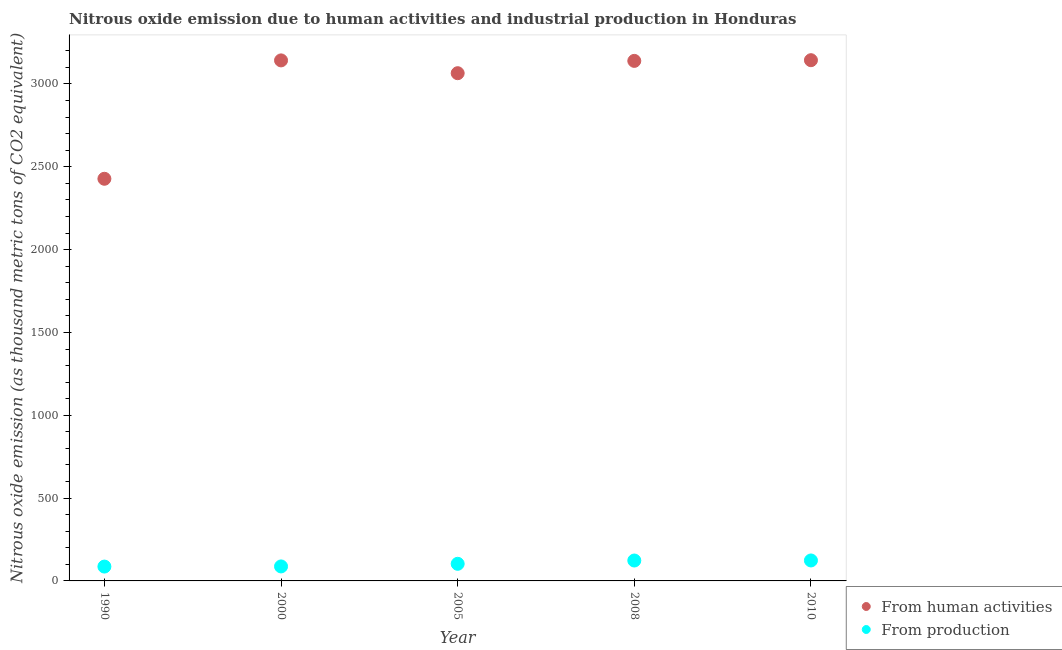What is the amount of emissions from human activities in 2010?
Provide a succinct answer. 3143.4. Across all years, what is the maximum amount of emissions generated from industries?
Your response must be concise. 123.5. Across all years, what is the minimum amount of emissions from human activities?
Give a very brief answer. 2427.6. In which year was the amount of emissions generated from industries minimum?
Provide a succinct answer. 1990. What is the total amount of emissions from human activities in the graph?
Your answer should be very brief. 1.49e+04. What is the difference between the amount of emissions from human activities in 2005 and that in 2010?
Keep it short and to the point. -78.5. What is the difference between the amount of emissions from human activities in 1990 and the amount of emissions generated from industries in 2005?
Make the answer very short. 2324.3. What is the average amount of emissions from human activities per year?
Your answer should be very brief. 2983.46. In the year 2005, what is the difference between the amount of emissions generated from industries and amount of emissions from human activities?
Offer a terse response. -2961.6. In how many years, is the amount of emissions from human activities greater than 1400 thousand metric tons?
Your response must be concise. 5. What is the ratio of the amount of emissions generated from industries in 2000 to that in 2008?
Give a very brief answer. 0.71. What is the difference between the highest and the second highest amount of emissions generated from industries?
Your response must be concise. 0.3. What is the difference between the highest and the lowest amount of emissions from human activities?
Provide a succinct answer. 715.8. Does the amount of emissions from human activities monotonically increase over the years?
Your response must be concise. No. How many dotlines are there?
Your response must be concise. 2. How many years are there in the graph?
Offer a terse response. 5. Are the values on the major ticks of Y-axis written in scientific E-notation?
Keep it short and to the point. No. How are the legend labels stacked?
Give a very brief answer. Vertical. What is the title of the graph?
Provide a succinct answer. Nitrous oxide emission due to human activities and industrial production in Honduras. What is the label or title of the X-axis?
Offer a very short reply. Year. What is the label or title of the Y-axis?
Your response must be concise. Nitrous oxide emission (as thousand metric tons of CO2 equivalent). What is the Nitrous oxide emission (as thousand metric tons of CO2 equivalent) in From human activities in 1990?
Ensure brevity in your answer.  2427.6. What is the Nitrous oxide emission (as thousand metric tons of CO2 equivalent) in From production in 1990?
Your answer should be compact. 86.6. What is the Nitrous oxide emission (as thousand metric tons of CO2 equivalent) of From human activities in 2000?
Make the answer very short. 3142.2. What is the Nitrous oxide emission (as thousand metric tons of CO2 equivalent) of From production in 2000?
Offer a terse response. 87.5. What is the Nitrous oxide emission (as thousand metric tons of CO2 equivalent) in From human activities in 2005?
Your answer should be very brief. 3064.9. What is the Nitrous oxide emission (as thousand metric tons of CO2 equivalent) in From production in 2005?
Make the answer very short. 103.3. What is the Nitrous oxide emission (as thousand metric tons of CO2 equivalent) in From human activities in 2008?
Provide a short and direct response. 3139.2. What is the Nitrous oxide emission (as thousand metric tons of CO2 equivalent) in From production in 2008?
Provide a succinct answer. 123.2. What is the Nitrous oxide emission (as thousand metric tons of CO2 equivalent) of From human activities in 2010?
Keep it short and to the point. 3143.4. What is the Nitrous oxide emission (as thousand metric tons of CO2 equivalent) in From production in 2010?
Your response must be concise. 123.5. Across all years, what is the maximum Nitrous oxide emission (as thousand metric tons of CO2 equivalent) of From human activities?
Provide a short and direct response. 3143.4. Across all years, what is the maximum Nitrous oxide emission (as thousand metric tons of CO2 equivalent) in From production?
Offer a terse response. 123.5. Across all years, what is the minimum Nitrous oxide emission (as thousand metric tons of CO2 equivalent) of From human activities?
Keep it short and to the point. 2427.6. Across all years, what is the minimum Nitrous oxide emission (as thousand metric tons of CO2 equivalent) of From production?
Offer a terse response. 86.6. What is the total Nitrous oxide emission (as thousand metric tons of CO2 equivalent) in From human activities in the graph?
Provide a short and direct response. 1.49e+04. What is the total Nitrous oxide emission (as thousand metric tons of CO2 equivalent) of From production in the graph?
Provide a short and direct response. 524.1. What is the difference between the Nitrous oxide emission (as thousand metric tons of CO2 equivalent) of From human activities in 1990 and that in 2000?
Ensure brevity in your answer.  -714.6. What is the difference between the Nitrous oxide emission (as thousand metric tons of CO2 equivalent) in From human activities in 1990 and that in 2005?
Ensure brevity in your answer.  -637.3. What is the difference between the Nitrous oxide emission (as thousand metric tons of CO2 equivalent) in From production in 1990 and that in 2005?
Ensure brevity in your answer.  -16.7. What is the difference between the Nitrous oxide emission (as thousand metric tons of CO2 equivalent) in From human activities in 1990 and that in 2008?
Your response must be concise. -711.6. What is the difference between the Nitrous oxide emission (as thousand metric tons of CO2 equivalent) of From production in 1990 and that in 2008?
Your answer should be very brief. -36.6. What is the difference between the Nitrous oxide emission (as thousand metric tons of CO2 equivalent) of From human activities in 1990 and that in 2010?
Your answer should be very brief. -715.8. What is the difference between the Nitrous oxide emission (as thousand metric tons of CO2 equivalent) of From production in 1990 and that in 2010?
Provide a succinct answer. -36.9. What is the difference between the Nitrous oxide emission (as thousand metric tons of CO2 equivalent) in From human activities in 2000 and that in 2005?
Give a very brief answer. 77.3. What is the difference between the Nitrous oxide emission (as thousand metric tons of CO2 equivalent) of From production in 2000 and that in 2005?
Give a very brief answer. -15.8. What is the difference between the Nitrous oxide emission (as thousand metric tons of CO2 equivalent) in From production in 2000 and that in 2008?
Provide a short and direct response. -35.7. What is the difference between the Nitrous oxide emission (as thousand metric tons of CO2 equivalent) of From human activities in 2000 and that in 2010?
Your answer should be very brief. -1.2. What is the difference between the Nitrous oxide emission (as thousand metric tons of CO2 equivalent) in From production in 2000 and that in 2010?
Make the answer very short. -36. What is the difference between the Nitrous oxide emission (as thousand metric tons of CO2 equivalent) in From human activities in 2005 and that in 2008?
Keep it short and to the point. -74.3. What is the difference between the Nitrous oxide emission (as thousand metric tons of CO2 equivalent) of From production in 2005 and that in 2008?
Your response must be concise. -19.9. What is the difference between the Nitrous oxide emission (as thousand metric tons of CO2 equivalent) of From human activities in 2005 and that in 2010?
Make the answer very short. -78.5. What is the difference between the Nitrous oxide emission (as thousand metric tons of CO2 equivalent) in From production in 2005 and that in 2010?
Your response must be concise. -20.2. What is the difference between the Nitrous oxide emission (as thousand metric tons of CO2 equivalent) of From production in 2008 and that in 2010?
Your answer should be compact. -0.3. What is the difference between the Nitrous oxide emission (as thousand metric tons of CO2 equivalent) in From human activities in 1990 and the Nitrous oxide emission (as thousand metric tons of CO2 equivalent) in From production in 2000?
Keep it short and to the point. 2340.1. What is the difference between the Nitrous oxide emission (as thousand metric tons of CO2 equivalent) of From human activities in 1990 and the Nitrous oxide emission (as thousand metric tons of CO2 equivalent) of From production in 2005?
Provide a succinct answer. 2324.3. What is the difference between the Nitrous oxide emission (as thousand metric tons of CO2 equivalent) in From human activities in 1990 and the Nitrous oxide emission (as thousand metric tons of CO2 equivalent) in From production in 2008?
Make the answer very short. 2304.4. What is the difference between the Nitrous oxide emission (as thousand metric tons of CO2 equivalent) of From human activities in 1990 and the Nitrous oxide emission (as thousand metric tons of CO2 equivalent) of From production in 2010?
Provide a short and direct response. 2304.1. What is the difference between the Nitrous oxide emission (as thousand metric tons of CO2 equivalent) of From human activities in 2000 and the Nitrous oxide emission (as thousand metric tons of CO2 equivalent) of From production in 2005?
Your answer should be very brief. 3038.9. What is the difference between the Nitrous oxide emission (as thousand metric tons of CO2 equivalent) of From human activities in 2000 and the Nitrous oxide emission (as thousand metric tons of CO2 equivalent) of From production in 2008?
Provide a short and direct response. 3019. What is the difference between the Nitrous oxide emission (as thousand metric tons of CO2 equivalent) in From human activities in 2000 and the Nitrous oxide emission (as thousand metric tons of CO2 equivalent) in From production in 2010?
Your answer should be compact. 3018.7. What is the difference between the Nitrous oxide emission (as thousand metric tons of CO2 equivalent) in From human activities in 2005 and the Nitrous oxide emission (as thousand metric tons of CO2 equivalent) in From production in 2008?
Give a very brief answer. 2941.7. What is the difference between the Nitrous oxide emission (as thousand metric tons of CO2 equivalent) in From human activities in 2005 and the Nitrous oxide emission (as thousand metric tons of CO2 equivalent) in From production in 2010?
Keep it short and to the point. 2941.4. What is the difference between the Nitrous oxide emission (as thousand metric tons of CO2 equivalent) in From human activities in 2008 and the Nitrous oxide emission (as thousand metric tons of CO2 equivalent) in From production in 2010?
Keep it short and to the point. 3015.7. What is the average Nitrous oxide emission (as thousand metric tons of CO2 equivalent) of From human activities per year?
Keep it short and to the point. 2983.46. What is the average Nitrous oxide emission (as thousand metric tons of CO2 equivalent) of From production per year?
Give a very brief answer. 104.82. In the year 1990, what is the difference between the Nitrous oxide emission (as thousand metric tons of CO2 equivalent) in From human activities and Nitrous oxide emission (as thousand metric tons of CO2 equivalent) in From production?
Keep it short and to the point. 2341. In the year 2000, what is the difference between the Nitrous oxide emission (as thousand metric tons of CO2 equivalent) in From human activities and Nitrous oxide emission (as thousand metric tons of CO2 equivalent) in From production?
Offer a terse response. 3054.7. In the year 2005, what is the difference between the Nitrous oxide emission (as thousand metric tons of CO2 equivalent) of From human activities and Nitrous oxide emission (as thousand metric tons of CO2 equivalent) of From production?
Provide a succinct answer. 2961.6. In the year 2008, what is the difference between the Nitrous oxide emission (as thousand metric tons of CO2 equivalent) in From human activities and Nitrous oxide emission (as thousand metric tons of CO2 equivalent) in From production?
Make the answer very short. 3016. In the year 2010, what is the difference between the Nitrous oxide emission (as thousand metric tons of CO2 equivalent) in From human activities and Nitrous oxide emission (as thousand metric tons of CO2 equivalent) in From production?
Ensure brevity in your answer.  3019.9. What is the ratio of the Nitrous oxide emission (as thousand metric tons of CO2 equivalent) of From human activities in 1990 to that in 2000?
Provide a short and direct response. 0.77. What is the ratio of the Nitrous oxide emission (as thousand metric tons of CO2 equivalent) in From human activities in 1990 to that in 2005?
Ensure brevity in your answer.  0.79. What is the ratio of the Nitrous oxide emission (as thousand metric tons of CO2 equivalent) of From production in 1990 to that in 2005?
Provide a succinct answer. 0.84. What is the ratio of the Nitrous oxide emission (as thousand metric tons of CO2 equivalent) of From human activities in 1990 to that in 2008?
Your answer should be very brief. 0.77. What is the ratio of the Nitrous oxide emission (as thousand metric tons of CO2 equivalent) in From production in 1990 to that in 2008?
Provide a succinct answer. 0.7. What is the ratio of the Nitrous oxide emission (as thousand metric tons of CO2 equivalent) of From human activities in 1990 to that in 2010?
Provide a succinct answer. 0.77. What is the ratio of the Nitrous oxide emission (as thousand metric tons of CO2 equivalent) of From production in 1990 to that in 2010?
Give a very brief answer. 0.7. What is the ratio of the Nitrous oxide emission (as thousand metric tons of CO2 equivalent) of From human activities in 2000 to that in 2005?
Offer a very short reply. 1.03. What is the ratio of the Nitrous oxide emission (as thousand metric tons of CO2 equivalent) in From production in 2000 to that in 2005?
Your answer should be very brief. 0.85. What is the ratio of the Nitrous oxide emission (as thousand metric tons of CO2 equivalent) of From production in 2000 to that in 2008?
Give a very brief answer. 0.71. What is the ratio of the Nitrous oxide emission (as thousand metric tons of CO2 equivalent) of From human activities in 2000 to that in 2010?
Your answer should be compact. 1. What is the ratio of the Nitrous oxide emission (as thousand metric tons of CO2 equivalent) of From production in 2000 to that in 2010?
Ensure brevity in your answer.  0.71. What is the ratio of the Nitrous oxide emission (as thousand metric tons of CO2 equivalent) in From human activities in 2005 to that in 2008?
Provide a short and direct response. 0.98. What is the ratio of the Nitrous oxide emission (as thousand metric tons of CO2 equivalent) in From production in 2005 to that in 2008?
Provide a short and direct response. 0.84. What is the ratio of the Nitrous oxide emission (as thousand metric tons of CO2 equivalent) of From human activities in 2005 to that in 2010?
Keep it short and to the point. 0.97. What is the ratio of the Nitrous oxide emission (as thousand metric tons of CO2 equivalent) of From production in 2005 to that in 2010?
Your answer should be very brief. 0.84. What is the ratio of the Nitrous oxide emission (as thousand metric tons of CO2 equivalent) in From human activities in 2008 to that in 2010?
Your answer should be very brief. 1. What is the ratio of the Nitrous oxide emission (as thousand metric tons of CO2 equivalent) in From production in 2008 to that in 2010?
Ensure brevity in your answer.  1. What is the difference between the highest and the second highest Nitrous oxide emission (as thousand metric tons of CO2 equivalent) in From production?
Provide a short and direct response. 0.3. What is the difference between the highest and the lowest Nitrous oxide emission (as thousand metric tons of CO2 equivalent) in From human activities?
Your answer should be very brief. 715.8. What is the difference between the highest and the lowest Nitrous oxide emission (as thousand metric tons of CO2 equivalent) in From production?
Your answer should be compact. 36.9. 